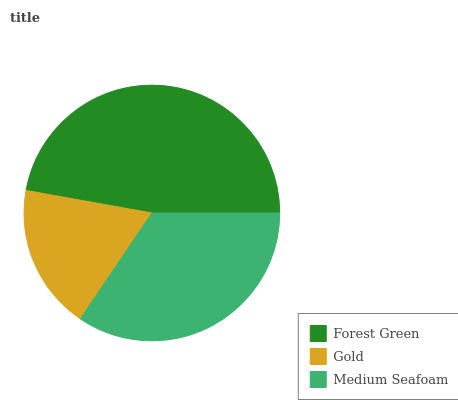Is Gold the minimum?
Answer yes or no. Yes. Is Forest Green the maximum?
Answer yes or no. Yes. Is Medium Seafoam the minimum?
Answer yes or no. No. Is Medium Seafoam the maximum?
Answer yes or no. No. Is Medium Seafoam greater than Gold?
Answer yes or no. Yes. Is Gold less than Medium Seafoam?
Answer yes or no. Yes. Is Gold greater than Medium Seafoam?
Answer yes or no. No. Is Medium Seafoam less than Gold?
Answer yes or no. No. Is Medium Seafoam the high median?
Answer yes or no. Yes. Is Medium Seafoam the low median?
Answer yes or no. Yes. Is Gold the high median?
Answer yes or no. No. Is Gold the low median?
Answer yes or no. No. 